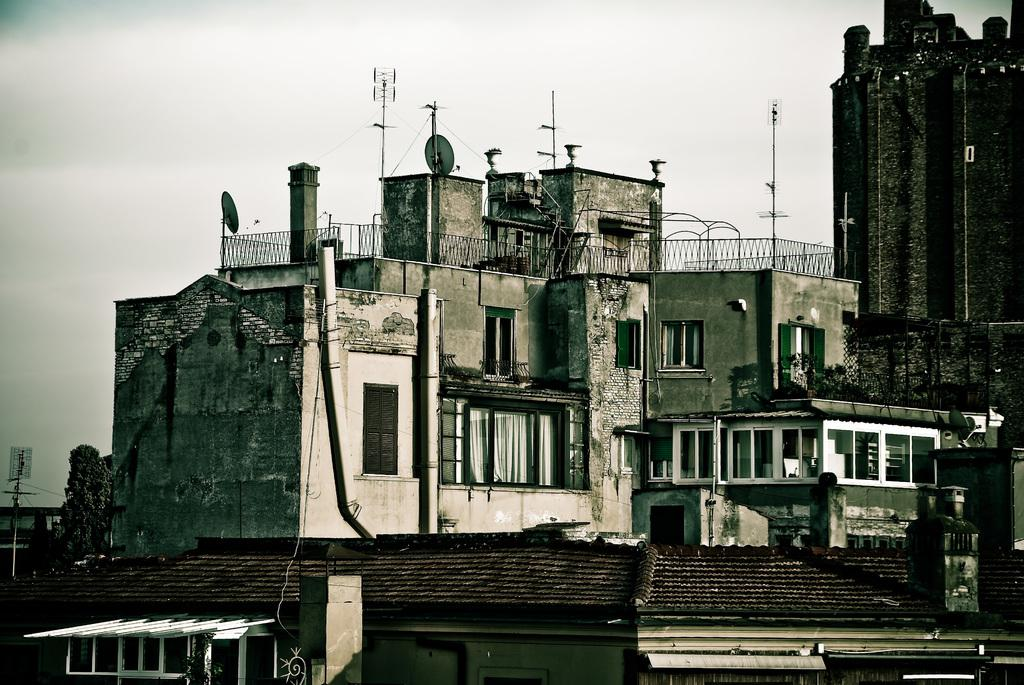What type of structures are present in the image? There are buildings in the image. What feature can be seen on the buildings? There are glass windows in the image. What objects are visible in the background of the image? There are poles in the background of the image. What type of barrier is present in the image? There is railing visible in the image. What is the color of the sky in the image? The sky appears to be white in color. What type of collar can be seen on the music in the image? There is no music or collar present in the image. 